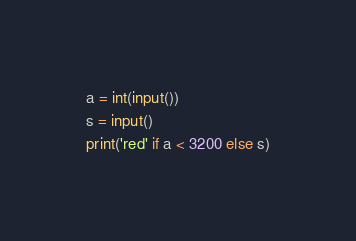Convert code to text. <code><loc_0><loc_0><loc_500><loc_500><_Python_>a = int(input())
s = input()
print('red' if a < 3200 else s)
</code> 